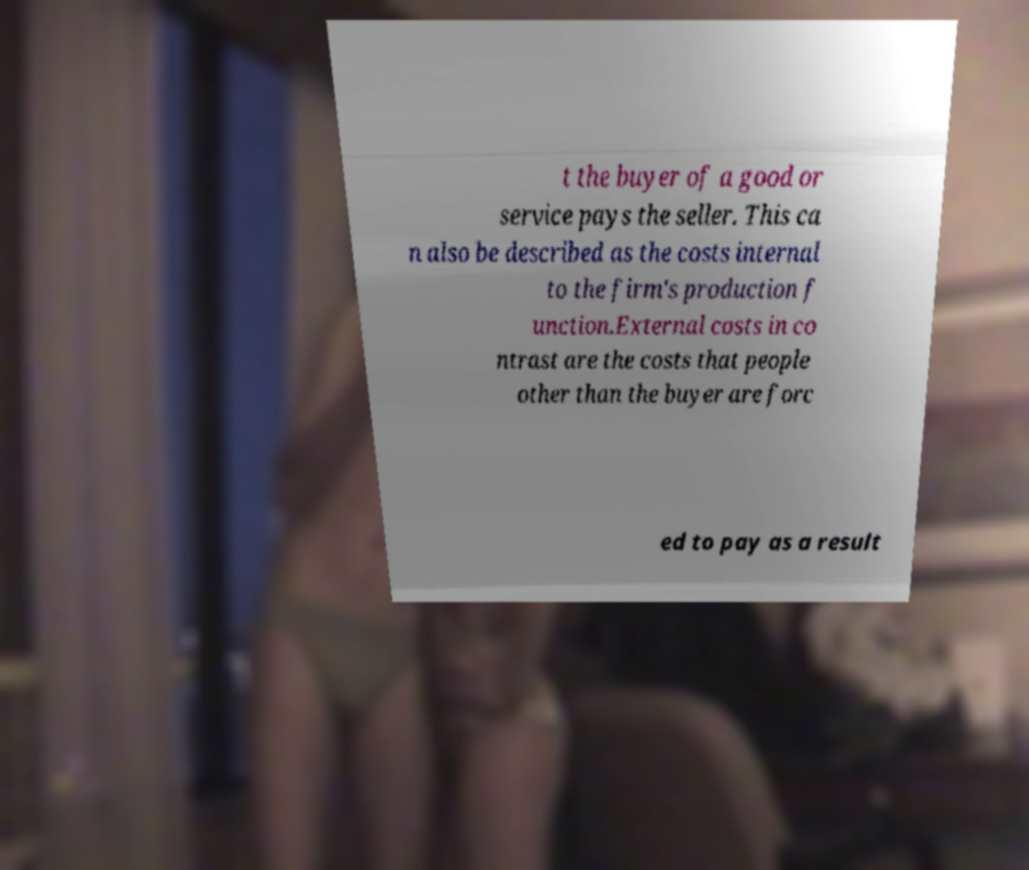I need the written content from this picture converted into text. Can you do that? t the buyer of a good or service pays the seller. This ca n also be described as the costs internal to the firm's production f unction.External costs in co ntrast are the costs that people other than the buyer are forc ed to pay as a result 